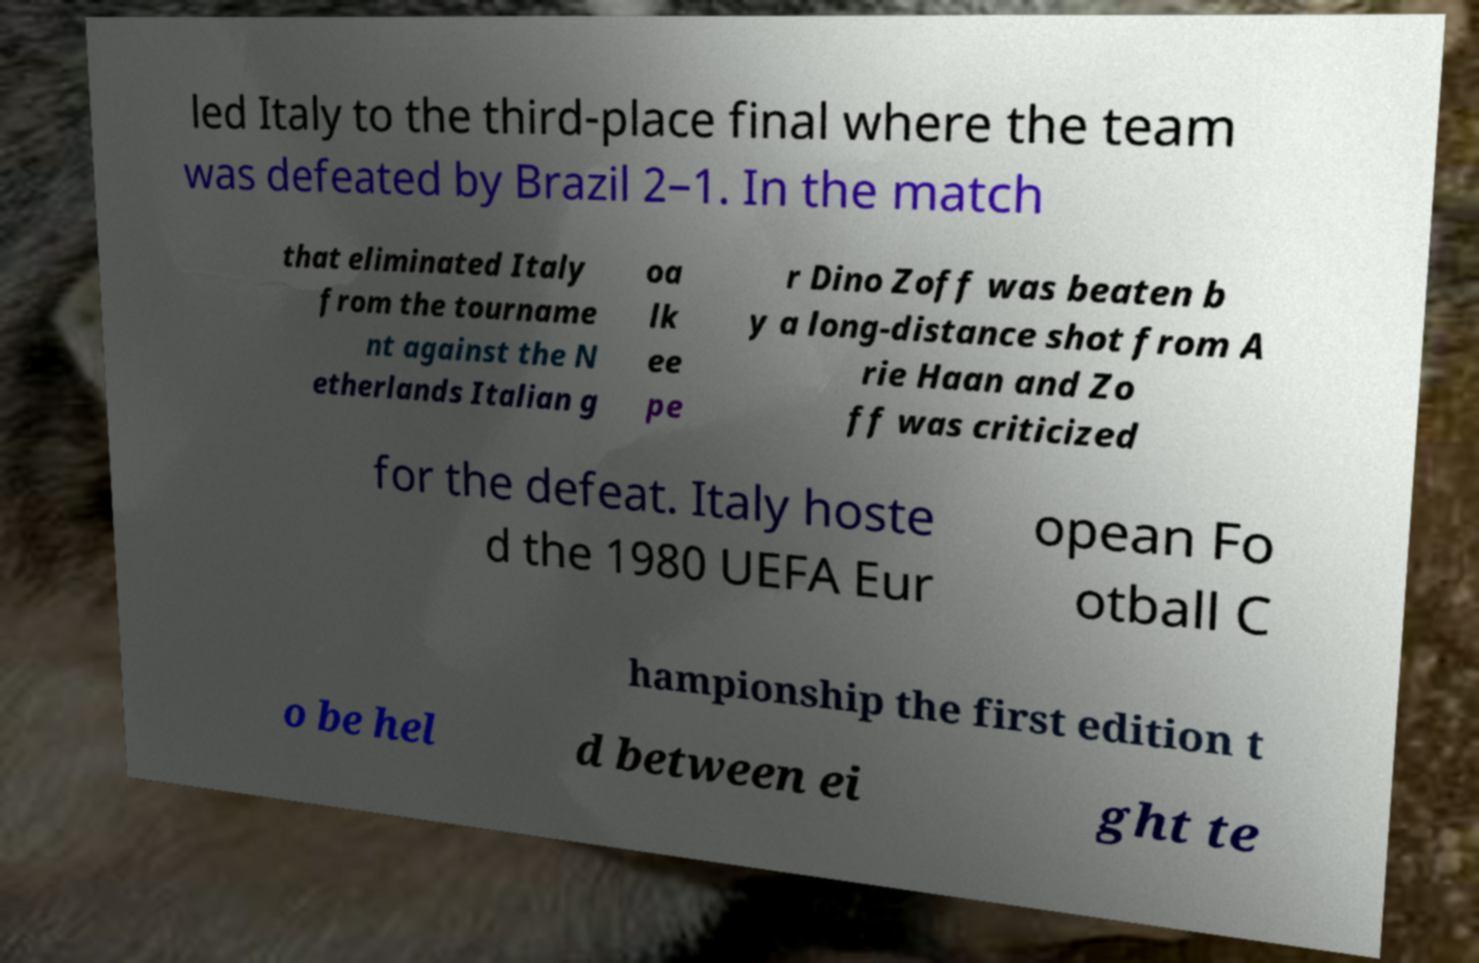What messages or text are displayed in this image? I need them in a readable, typed format. led Italy to the third-place final where the team was defeated by Brazil 2–1. In the match that eliminated Italy from the tourname nt against the N etherlands Italian g oa lk ee pe r Dino Zoff was beaten b y a long-distance shot from A rie Haan and Zo ff was criticized for the defeat. Italy hoste d the 1980 UEFA Eur opean Fo otball C hampionship the first edition t o be hel d between ei ght te 